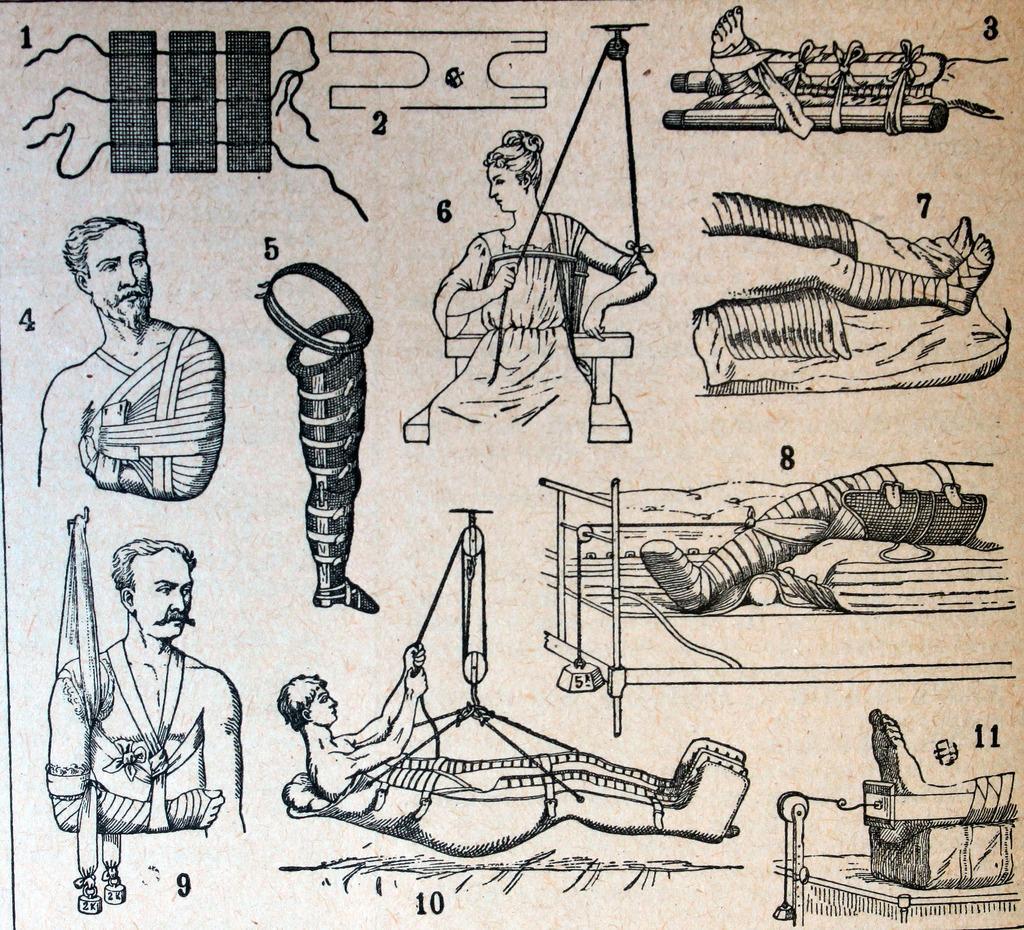In one or two sentences, can you explain what this image depicts? This is an animated image with the numbers and images of the persons and objects in it. 